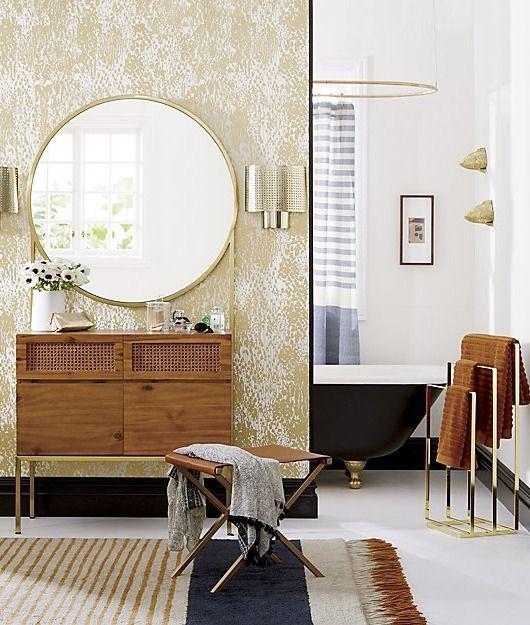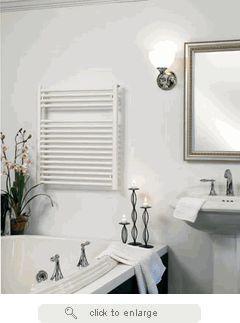The first image is the image on the left, the second image is the image on the right. Assess this claim about the two images: "In one image, a white pedestal sink stands against a wall.". Correct or not? Answer yes or no. Yes. The first image is the image on the left, the second image is the image on the right. For the images shown, is this caption "There are at least two mirrors visible hanging on the walls." true? Answer yes or no. Yes. 